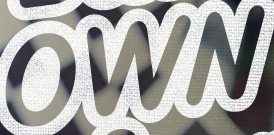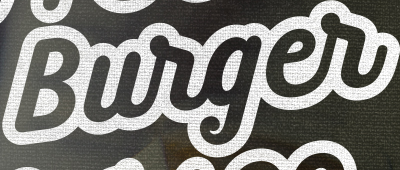What text is displayed in these images sequentially, separated by a semicolon? OWN; Burger 